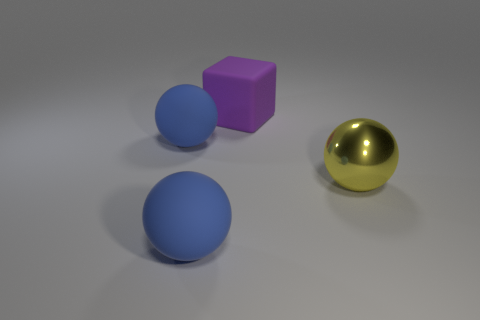What could be the possible size of these objects in a real-world setting? Without a reference object for scale, it's difficult to determine the exact size. However, these objects could be representative of real-world items ranging from small decorative spheres and a block, like those used in a tabletop game, to larger sculptures that might be found in a public space or gallery. 